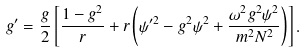<formula> <loc_0><loc_0><loc_500><loc_500>g ^ { \prime } = \frac { g } { 2 } \left [ \frac { 1 - g ^ { 2 } } r + r \left ( \psi ^ { \prime 2 } - g ^ { 2 } \psi ^ { 2 } + \frac { \omega ^ { 2 } g ^ { 2 } \psi ^ { 2 } } { m ^ { 2 } N ^ { 2 } } \right ) \right ] .</formula> 